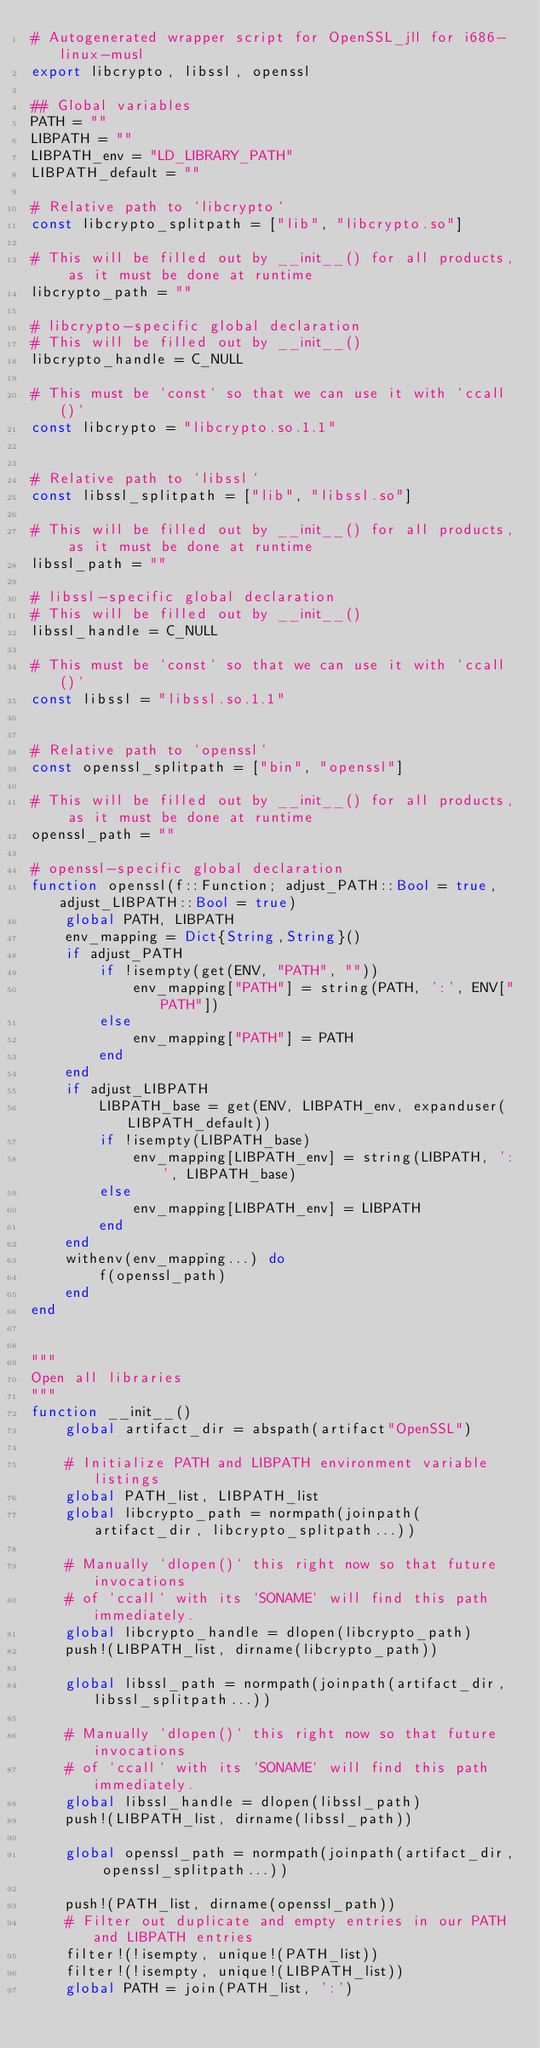Convert code to text. <code><loc_0><loc_0><loc_500><loc_500><_Julia_># Autogenerated wrapper script for OpenSSL_jll for i686-linux-musl
export libcrypto, libssl, openssl

## Global variables
PATH = ""
LIBPATH = ""
LIBPATH_env = "LD_LIBRARY_PATH"
LIBPATH_default = ""

# Relative path to `libcrypto`
const libcrypto_splitpath = ["lib", "libcrypto.so"]

# This will be filled out by __init__() for all products, as it must be done at runtime
libcrypto_path = ""

# libcrypto-specific global declaration
# This will be filled out by __init__()
libcrypto_handle = C_NULL

# This must be `const` so that we can use it with `ccall()`
const libcrypto = "libcrypto.so.1.1"


# Relative path to `libssl`
const libssl_splitpath = ["lib", "libssl.so"]

# This will be filled out by __init__() for all products, as it must be done at runtime
libssl_path = ""

# libssl-specific global declaration
# This will be filled out by __init__()
libssl_handle = C_NULL

# This must be `const` so that we can use it with `ccall()`
const libssl = "libssl.so.1.1"


# Relative path to `openssl`
const openssl_splitpath = ["bin", "openssl"]

# This will be filled out by __init__() for all products, as it must be done at runtime
openssl_path = ""

# openssl-specific global declaration
function openssl(f::Function; adjust_PATH::Bool = true, adjust_LIBPATH::Bool = true)
    global PATH, LIBPATH
    env_mapping = Dict{String,String}()
    if adjust_PATH
        if !isempty(get(ENV, "PATH", ""))
            env_mapping["PATH"] = string(PATH, ':', ENV["PATH"])
        else
            env_mapping["PATH"] = PATH
        end
    end
    if adjust_LIBPATH
        LIBPATH_base = get(ENV, LIBPATH_env, expanduser(LIBPATH_default))
        if !isempty(LIBPATH_base)
            env_mapping[LIBPATH_env] = string(LIBPATH, ':', LIBPATH_base)
        else
            env_mapping[LIBPATH_env] = LIBPATH
        end
    end
    withenv(env_mapping...) do
        f(openssl_path)
    end
end


"""
Open all libraries
"""
function __init__()
    global artifact_dir = abspath(artifact"OpenSSL")

    # Initialize PATH and LIBPATH environment variable listings
    global PATH_list, LIBPATH_list
    global libcrypto_path = normpath(joinpath(artifact_dir, libcrypto_splitpath...))

    # Manually `dlopen()` this right now so that future invocations
    # of `ccall` with its `SONAME` will find this path immediately.
    global libcrypto_handle = dlopen(libcrypto_path)
    push!(LIBPATH_list, dirname(libcrypto_path))

    global libssl_path = normpath(joinpath(artifact_dir, libssl_splitpath...))

    # Manually `dlopen()` this right now so that future invocations
    # of `ccall` with its `SONAME` will find this path immediately.
    global libssl_handle = dlopen(libssl_path)
    push!(LIBPATH_list, dirname(libssl_path))

    global openssl_path = normpath(joinpath(artifact_dir, openssl_splitpath...))

    push!(PATH_list, dirname(openssl_path))
    # Filter out duplicate and empty entries in our PATH and LIBPATH entries
    filter!(!isempty, unique!(PATH_list))
    filter!(!isempty, unique!(LIBPATH_list))
    global PATH = join(PATH_list, ':')</code> 